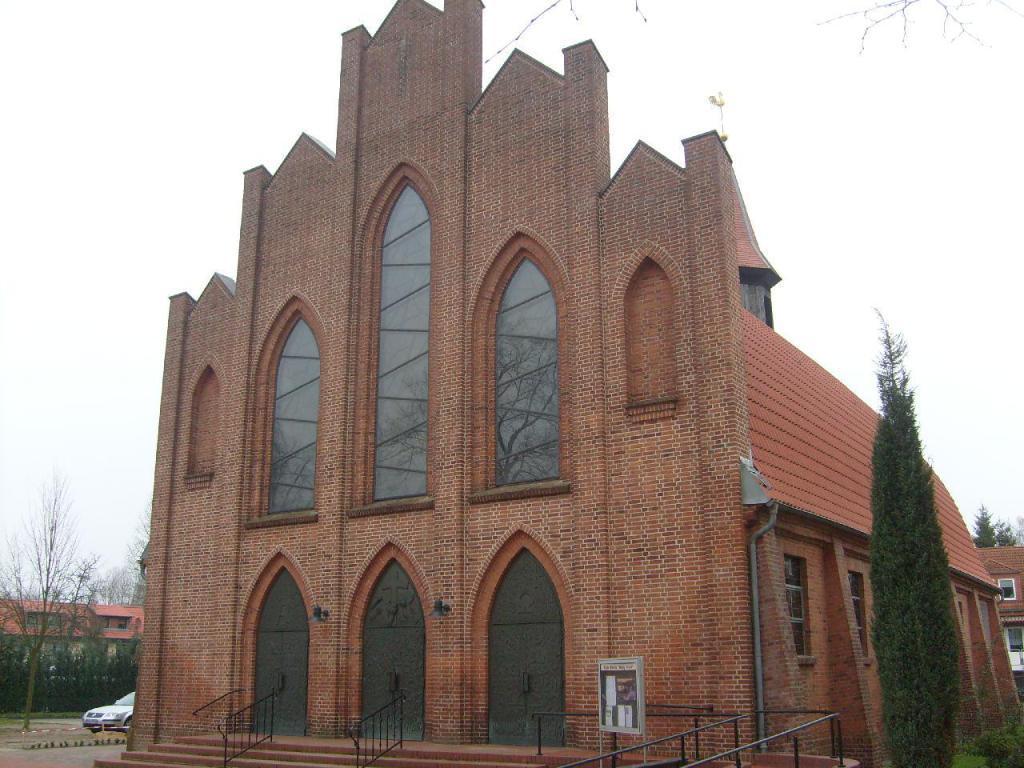Describe this image in one or two sentences. This image consists of a building. It has doors and stairs in the bottom. There are trees on the right side and left side. There are buildings on the left side and right side. There is sky on the top. There is a car in the left side bottom corner. To this building there are windows. 